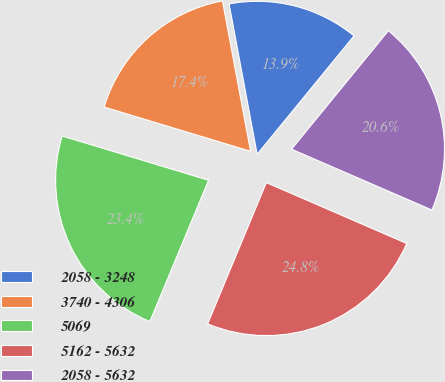Convert chart. <chart><loc_0><loc_0><loc_500><loc_500><pie_chart><fcel>2058 - 3248<fcel>3740 - 4306<fcel>5069<fcel>5162 - 5632<fcel>2058 - 5632<nl><fcel>13.85%<fcel>17.39%<fcel>23.4%<fcel>24.76%<fcel>20.6%<nl></chart> 